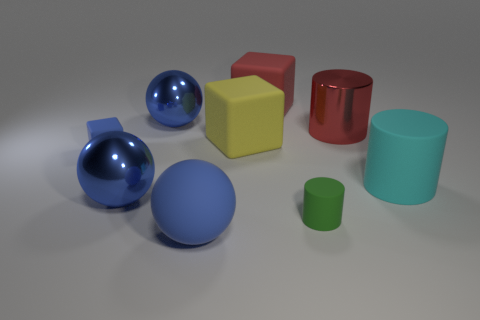What is the big red cylinder made of?
Ensure brevity in your answer.  Metal. How many other objects are there of the same material as the large yellow block?
Your response must be concise. 5. What number of red rubber blocks are there?
Your answer should be compact. 1. What material is the cyan thing that is the same shape as the green object?
Provide a succinct answer. Rubber. Are the tiny thing to the left of the rubber ball and the big red cylinder made of the same material?
Make the answer very short. No. Are there more green things that are left of the blue cube than red metallic things in front of the small green object?
Your response must be concise. No. What size is the green thing?
Your response must be concise. Small. The tiny green thing that is the same material as the big yellow object is what shape?
Make the answer very short. Cylinder. Does the big metal object that is on the right side of the large red rubber block have the same shape as the large cyan rubber thing?
Offer a terse response. Yes. What number of things are red things or blue rubber cylinders?
Your response must be concise. 2. 